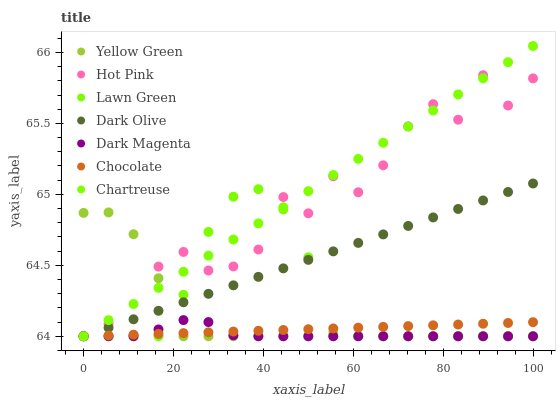Does Dark Magenta have the minimum area under the curve?
Answer yes or no. Yes. Does Chartreuse have the maximum area under the curve?
Answer yes or no. Yes. Does Hot Pink have the minimum area under the curve?
Answer yes or no. No. Does Hot Pink have the maximum area under the curve?
Answer yes or no. No. Is Chocolate the smoothest?
Answer yes or no. Yes. Is Hot Pink the roughest?
Answer yes or no. Yes. Is Yellow Green the smoothest?
Answer yes or no. No. Is Yellow Green the roughest?
Answer yes or no. No. Does Lawn Green have the lowest value?
Answer yes or no. Yes. Does Chartreuse have the highest value?
Answer yes or no. Yes. Does Hot Pink have the highest value?
Answer yes or no. No. Does Yellow Green intersect Chartreuse?
Answer yes or no. Yes. Is Yellow Green less than Chartreuse?
Answer yes or no. No. Is Yellow Green greater than Chartreuse?
Answer yes or no. No. 